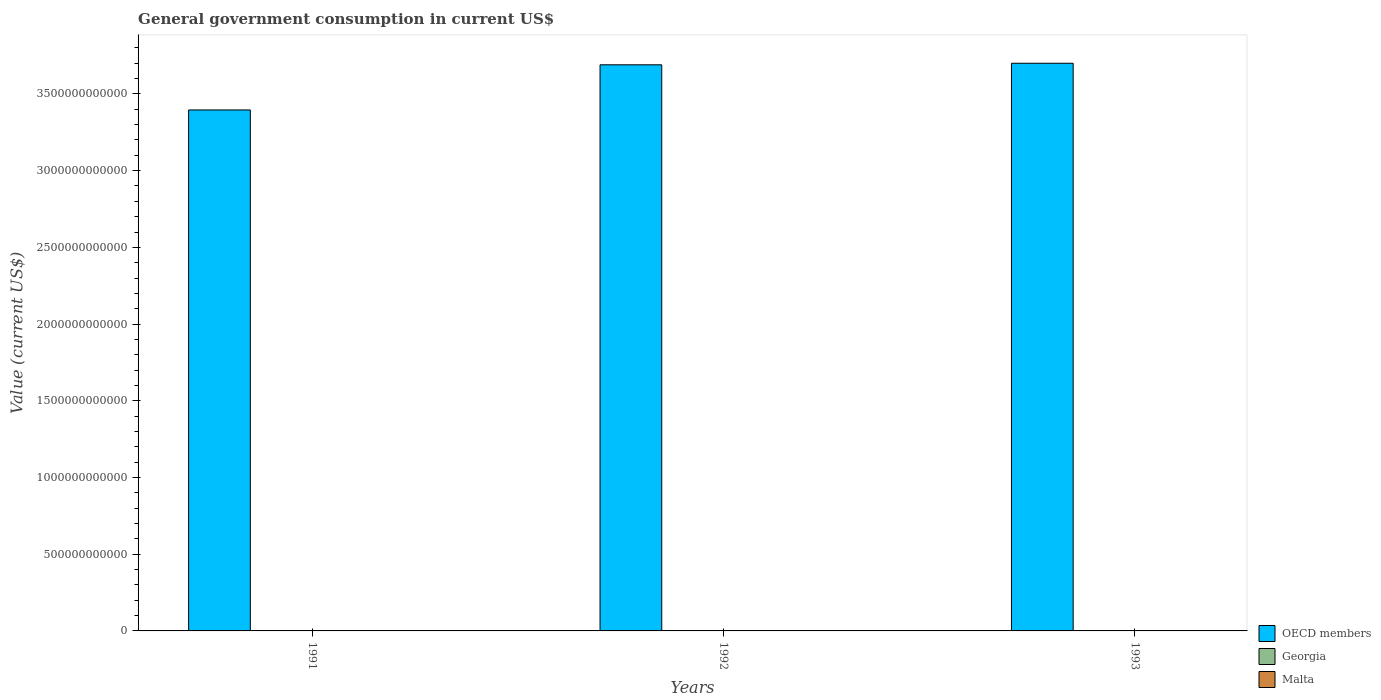How many different coloured bars are there?
Offer a very short reply. 3. How many groups of bars are there?
Keep it short and to the point. 3. What is the label of the 3rd group of bars from the left?
Keep it short and to the point. 1993. In how many cases, is the number of bars for a given year not equal to the number of legend labels?
Make the answer very short. 0. What is the government conusmption in Malta in 1991?
Your answer should be very brief. 4.63e+08. Across all years, what is the maximum government conusmption in OECD members?
Offer a very short reply. 3.70e+12. Across all years, what is the minimum government conusmption in Georgia?
Your answer should be compact. 1.58e+08. In which year was the government conusmption in Malta maximum?
Offer a terse response. 1992. In which year was the government conusmption in OECD members minimum?
Ensure brevity in your answer.  1991. What is the total government conusmption in Malta in the graph?
Make the answer very short. 1.49e+09. What is the difference between the government conusmption in Malta in 1991 and that in 1992?
Your response must be concise. -6.14e+07. What is the difference between the government conusmption in Georgia in 1993 and the government conusmption in Malta in 1991?
Your answer should be very brief. -3.04e+08. What is the average government conusmption in OECD members per year?
Make the answer very short. 3.60e+12. In the year 1992, what is the difference between the government conusmption in Georgia and government conusmption in OECD members?
Offer a very short reply. -3.69e+12. In how many years, is the government conusmption in OECD members greater than 1700000000000 US$?
Make the answer very short. 3. What is the ratio of the government conusmption in Malta in 1992 to that in 1993?
Give a very brief answer. 1.04. Is the government conusmption in OECD members in 1991 less than that in 1992?
Keep it short and to the point. Yes. What is the difference between the highest and the second highest government conusmption in Malta?
Keep it short and to the point. 2.16e+07. What is the difference between the highest and the lowest government conusmption in Georgia?
Offer a very short reply. 4.38e+08. In how many years, is the government conusmption in Malta greater than the average government conusmption in Malta taken over all years?
Keep it short and to the point. 2. Is the sum of the government conusmption in Georgia in 1992 and 1993 greater than the maximum government conusmption in Malta across all years?
Provide a succinct answer. No. What does the 1st bar from the left in 1992 represents?
Keep it short and to the point. OECD members. What does the 1st bar from the right in 1991 represents?
Provide a short and direct response. Malta. How many bars are there?
Your answer should be compact. 9. How many years are there in the graph?
Offer a terse response. 3. What is the difference between two consecutive major ticks on the Y-axis?
Ensure brevity in your answer.  5.00e+11. Does the graph contain grids?
Ensure brevity in your answer.  No. How are the legend labels stacked?
Your answer should be very brief. Vertical. What is the title of the graph?
Your answer should be compact. General government consumption in current US$. Does "El Salvador" appear as one of the legend labels in the graph?
Ensure brevity in your answer.  No. What is the label or title of the Y-axis?
Keep it short and to the point. Value (current US$). What is the Value (current US$) of OECD members in 1991?
Give a very brief answer. 3.40e+12. What is the Value (current US$) in Georgia in 1991?
Your answer should be compact. 5.96e+08. What is the Value (current US$) of Malta in 1991?
Give a very brief answer. 4.63e+08. What is the Value (current US$) of OECD members in 1992?
Your answer should be very brief. 3.69e+12. What is the Value (current US$) of Georgia in 1992?
Keep it short and to the point. 3.46e+08. What is the Value (current US$) of Malta in 1992?
Your answer should be compact. 5.24e+08. What is the Value (current US$) in OECD members in 1993?
Provide a succinct answer. 3.70e+12. What is the Value (current US$) in Georgia in 1993?
Your response must be concise. 1.58e+08. What is the Value (current US$) in Malta in 1993?
Keep it short and to the point. 5.03e+08. Across all years, what is the maximum Value (current US$) in OECD members?
Give a very brief answer. 3.70e+12. Across all years, what is the maximum Value (current US$) of Georgia?
Your answer should be very brief. 5.96e+08. Across all years, what is the maximum Value (current US$) of Malta?
Provide a short and direct response. 5.24e+08. Across all years, what is the minimum Value (current US$) of OECD members?
Provide a short and direct response. 3.40e+12. Across all years, what is the minimum Value (current US$) of Georgia?
Ensure brevity in your answer.  1.58e+08. Across all years, what is the minimum Value (current US$) in Malta?
Your answer should be very brief. 4.63e+08. What is the total Value (current US$) of OECD members in the graph?
Give a very brief answer. 1.08e+13. What is the total Value (current US$) of Georgia in the graph?
Keep it short and to the point. 1.10e+09. What is the total Value (current US$) of Malta in the graph?
Give a very brief answer. 1.49e+09. What is the difference between the Value (current US$) in OECD members in 1991 and that in 1992?
Your response must be concise. -2.94e+11. What is the difference between the Value (current US$) in Georgia in 1991 and that in 1992?
Offer a very short reply. 2.50e+08. What is the difference between the Value (current US$) of Malta in 1991 and that in 1992?
Offer a terse response. -6.14e+07. What is the difference between the Value (current US$) in OECD members in 1991 and that in 1993?
Offer a very short reply. -3.04e+11. What is the difference between the Value (current US$) of Georgia in 1991 and that in 1993?
Offer a terse response. 4.38e+08. What is the difference between the Value (current US$) of Malta in 1991 and that in 1993?
Your answer should be compact. -3.98e+07. What is the difference between the Value (current US$) in OECD members in 1992 and that in 1993?
Make the answer very short. -1.01e+1. What is the difference between the Value (current US$) in Georgia in 1992 and that in 1993?
Provide a short and direct response. 1.88e+08. What is the difference between the Value (current US$) in Malta in 1992 and that in 1993?
Make the answer very short. 2.16e+07. What is the difference between the Value (current US$) in OECD members in 1991 and the Value (current US$) in Georgia in 1992?
Offer a terse response. 3.40e+12. What is the difference between the Value (current US$) in OECD members in 1991 and the Value (current US$) in Malta in 1992?
Give a very brief answer. 3.39e+12. What is the difference between the Value (current US$) of Georgia in 1991 and the Value (current US$) of Malta in 1992?
Offer a very short reply. 7.18e+07. What is the difference between the Value (current US$) in OECD members in 1991 and the Value (current US$) in Georgia in 1993?
Give a very brief answer. 3.40e+12. What is the difference between the Value (current US$) of OECD members in 1991 and the Value (current US$) of Malta in 1993?
Give a very brief answer. 3.39e+12. What is the difference between the Value (current US$) in Georgia in 1991 and the Value (current US$) in Malta in 1993?
Keep it short and to the point. 9.35e+07. What is the difference between the Value (current US$) of OECD members in 1992 and the Value (current US$) of Georgia in 1993?
Provide a short and direct response. 3.69e+12. What is the difference between the Value (current US$) of OECD members in 1992 and the Value (current US$) of Malta in 1993?
Give a very brief answer. 3.69e+12. What is the difference between the Value (current US$) of Georgia in 1992 and the Value (current US$) of Malta in 1993?
Your answer should be very brief. -1.56e+08. What is the average Value (current US$) of OECD members per year?
Give a very brief answer. 3.60e+12. What is the average Value (current US$) of Georgia per year?
Give a very brief answer. 3.67e+08. What is the average Value (current US$) in Malta per year?
Offer a very short reply. 4.97e+08. In the year 1991, what is the difference between the Value (current US$) in OECD members and Value (current US$) in Georgia?
Your response must be concise. 3.39e+12. In the year 1991, what is the difference between the Value (current US$) of OECD members and Value (current US$) of Malta?
Provide a succinct answer. 3.39e+12. In the year 1991, what is the difference between the Value (current US$) in Georgia and Value (current US$) in Malta?
Keep it short and to the point. 1.33e+08. In the year 1992, what is the difference between the Value (current US$) of OECD members and Value (current US$) of Georgia?
Your answer should be compact. 3.69e+12. In the year 1992, what is the difference between the Value (current US$) of OECD members and Value (current US$) of Malta?
Your response must be concise. 3.69e+12. In the year 1992, what is the difference between the Value (current US$) in Georgia and Value (current US$) in Malta?
Make the answer very short. -1.78e+08. In the year 1993, what is the difference between the Value (current US$) in OECD members and Value (current US$) in Georgia?
Your response must be concise. 3.70e+12. In the year 1993, what is the difference between the Value (current US$) of OECD members and Value (current US$) of Malta?
Your answer should be compact. 3.70e+12. In the year 1993, what is the difference between the Value (current US$) of Georgia and Value (current US$) of Malta?
Your answer should be compact. -3.44e+08. What is the ratio of the Value (current US$) in OECD members in 1991 to that in 1992?
Provide a succinct answer. 0.92. What is the ratio of the Value (current US$) of Georgia in 1991 to that in 1992?
Make the answer very short. 1.72. What is the ratio of the Value (current US$) in Malta in 1991 to that in 1992?
Offer a terse response. 0.88. What is the ratio of the Value (current US$) in OECD members in 1991 to that in 1993?
Offer a very short reply. 0.92. What is the ratio of the Value (current US$) in Georgia in 1991 to that in 1993?
Provide a short and direct response. 3.76. What is the ratio of the Value (current US$) of Malta in 1991 to that in 1993?
Keep it short and to the point. 0.92. What is the ratio of the Value (current US$) in Georgia in 1992 to that in 1993?
Your answer should be very brief. 2.19. What is the ratio of the Value (current US$) in Malta in 1992 to that in 1993?
Keep it short and to the point. 1.04. What is the difference between the highest and the second highest Value (current US$) of OECD members?
Give a very brief answer. 1.01e+1. What is the difference between the highest and the second highest Value (current US$) of Georgia?
Your answer should be very brief. 2.50e+08. What is the difference between the highest and the second highest Value (current US$) in Malta?
Make the answer very short. 2.16e+07. What is the difference between the highest and the lowest Value (current US$) of OECD members?
Give a very brief answer. 3.04e+11. What is the difference between the highest and the lowest Value (current US$) of Georgia?
Provide a succinct answer. 4.38e+08. What is the difference between the highest and the lowest Value (current US$) in Malta?
Provide a short and direct response. 6.14e+07. 